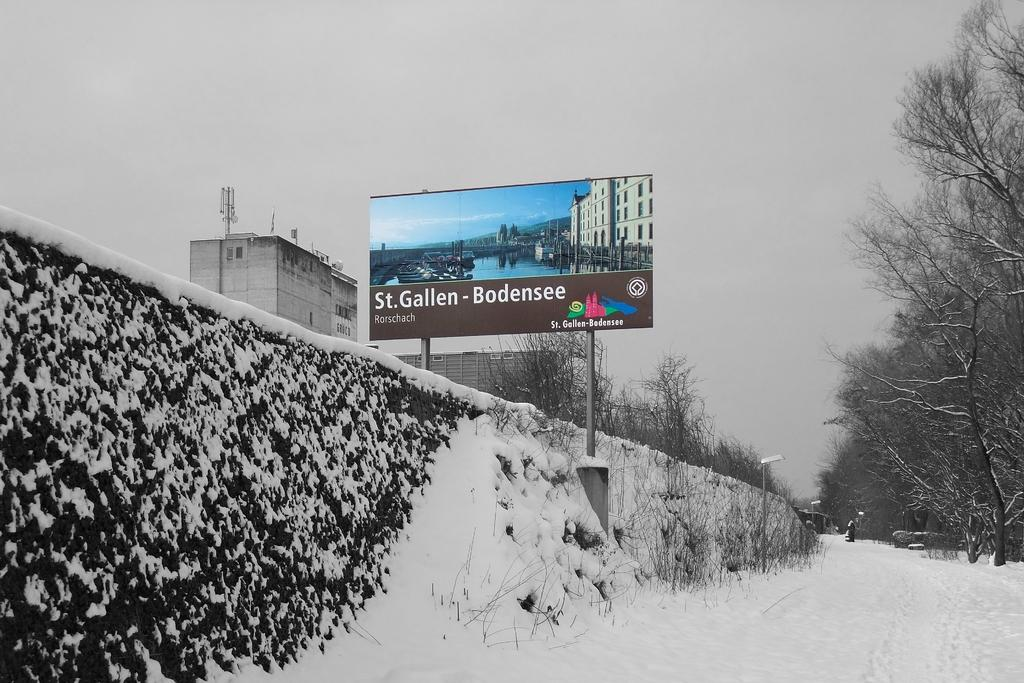What is the main structure visible in the image? There is a hoarding in the image. What other structures can be seen in the image? There is a wall, buildings, and light poles in the image. What type of natural elements are present in the image? There are trees and snow in the image. What else can be seen in the image besides structures and natural elements? There are some objects in the image. What is visible in the background of the image? The sky is visible in the background of the image. Can you see the agreement between the two parties in the image? There is no agreement visible in the image; it features a hoarding, wall, trees, snow, buildings, light poles, and objects. What type of spot is present on the wall in the image? There is no spot visible on the wall in the image. 